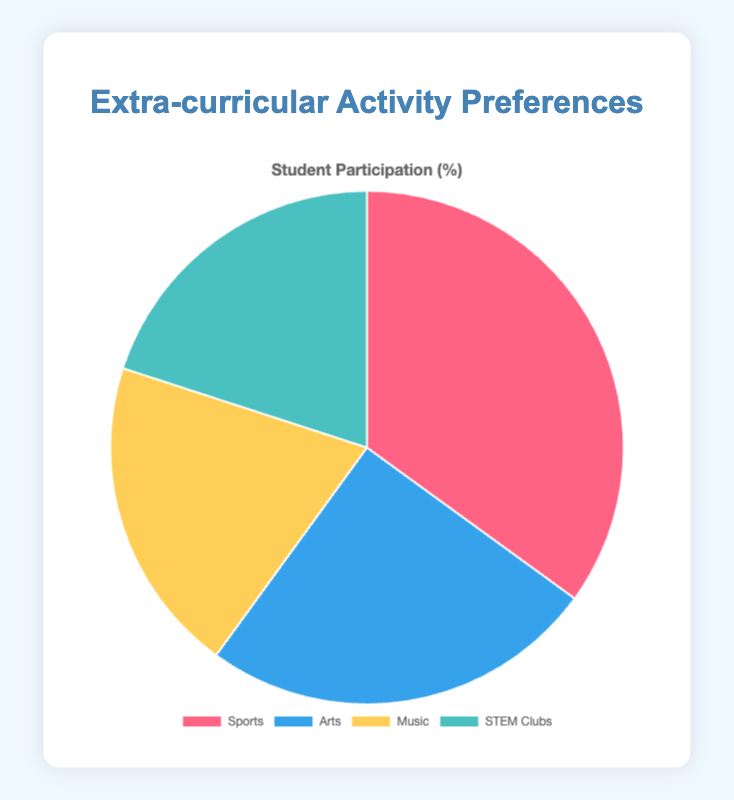Which activity has the highest percentage of student participation? The pie chart shows the percentage distribution of student participation in each activity. The activity with the highest percentage will occupy the largest portion of the pie chart. By observing, we see that "Sports" occupies the largest portion with 35%.
Answer: Sports Compare the percentage of student participation between Music and STEM Clubs. To compare the percentages, we look at the values for Music and STEM Clubs in the pie chart. Both activities have an equal participation percentage of 20%.
Answer: Equal How much more popular is Sports compared to Arts? To find how much more popular Sports is than Arts, we subtract the percentage of Arts from Sports. Sports is 35% and Arts is 25%. So, 35% - 25% = 10%.
Answer: 10% What is the total percentage of student participation in non-sports activities? Non-sports activities include Arts, Music, and STEM Clubs. To find the total percentage, we add these values together: 25% (Arts) + 20% (Music) + 20% (STEM Clubs) = 65%.
Answer: 65% Rank the activities from the highest to the lowest percentage of student participation. By observing the pie chart, we order the activities by their percentages: 35% (Sports), 25% (Arts), 20% (Music), 20% (STEM Clubs).
Answer: Sports, Arts, Music, STEM Clubs What percentage of students do not participate in Sports? To find the percentage of students who do not participate in Sports, we need to subtract Sports' percentage from 100%. So, 100% - 35% = 65%.
Answer: 65% If the school has 800 students, how many students participate in STEM Clubs? To find the number of students participating in STEM Clubs, we calculate 20% of 800. This equals 0.20 * 800 = 160 students.
Answer: 160 students What is the difference in student participation percentages between the most and least popular activities? The most popular activity is Sports with 35%, and the least popular activities are Music and STEM Clubs with 20% each. The difference is 35% - 20% = 15%.
Answer: 15% Are there any activities with the same percentage of student participation? By examining the pie chart, we see that both Music and STEM Clubs have the same participation percentage of 20%.
Answer: Yes What color represents the Arts activity in the pie chart? By referring to the color representation in the pie chart, we see that Arts is represented by the color blue.
Answer: Blue 